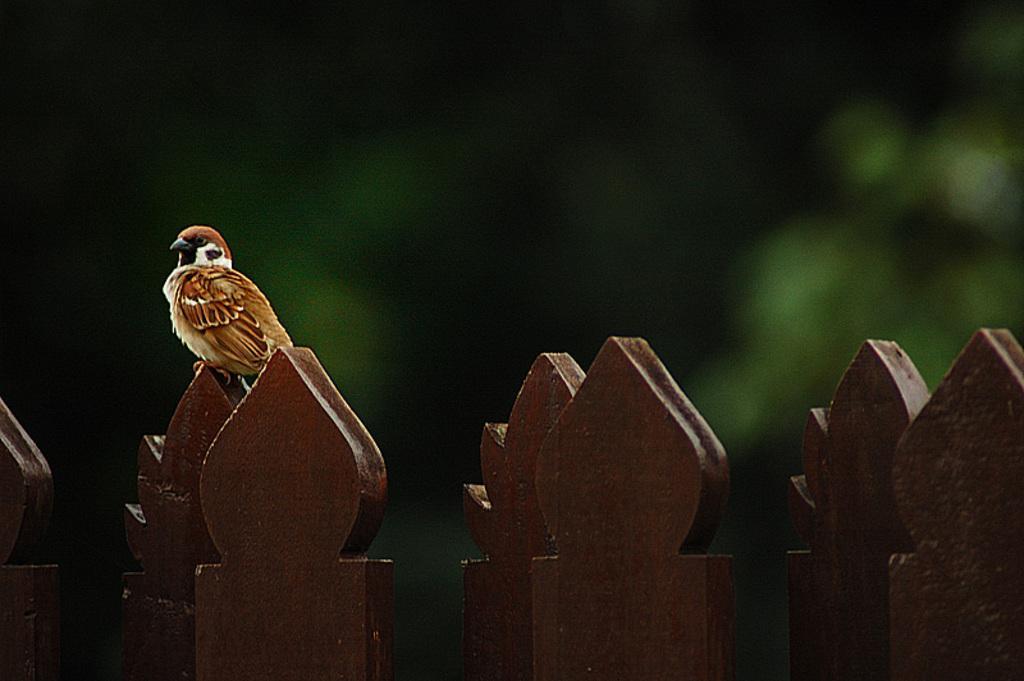Can you describe this image briefly? At the bottom of the picture, we see the wooden fence and we see the bird is on the wooden fence. It is in brown color. In the background, it is in green color. This picture is blurred in the background. 